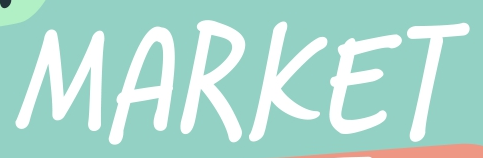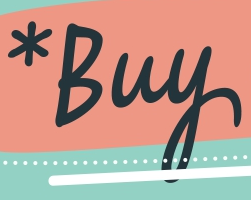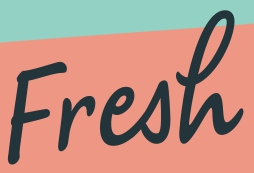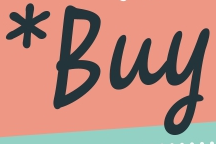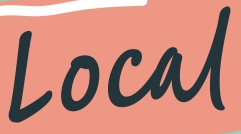What words can you see in these images in sequence, separated by a semicolon? MARKET; *Buy; Fresh; *Buy; Local 